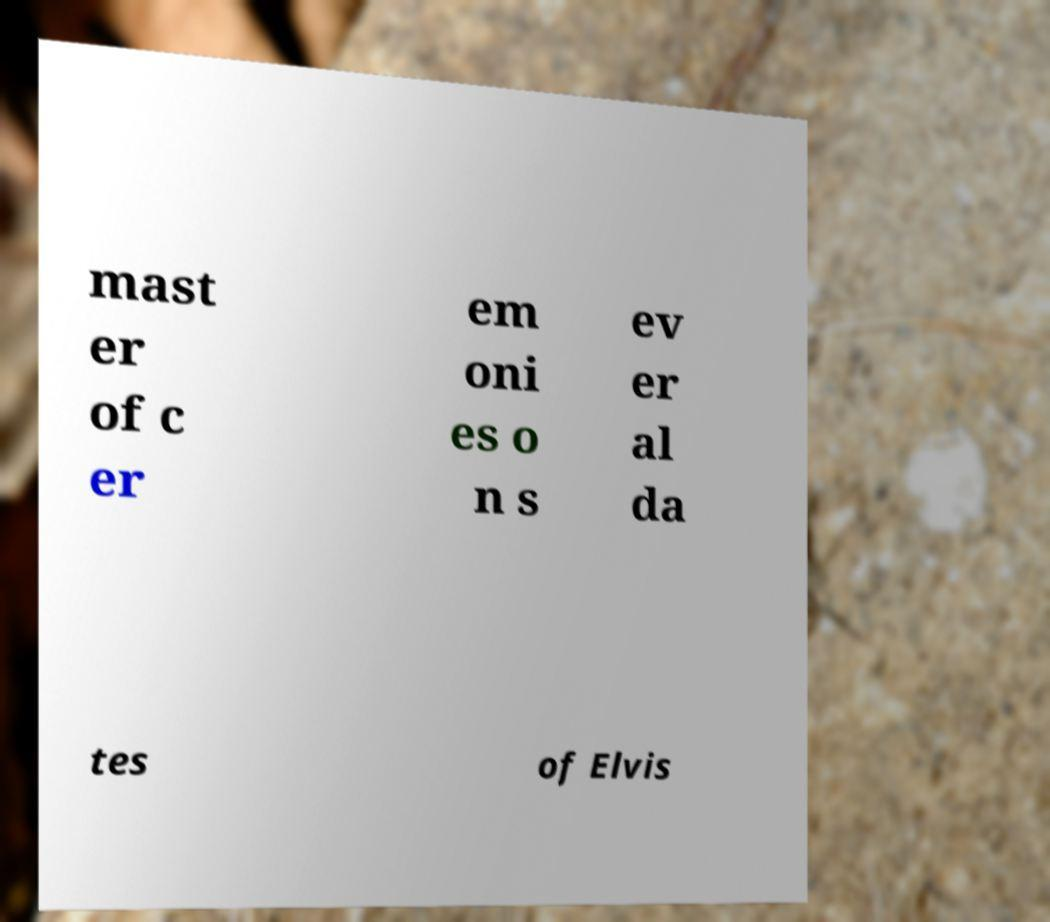There's text embedded in this image that I need extracted. Can you transcribe it verbatim? mast er of c er em oni es o n s ev er al da tes of Elvis 